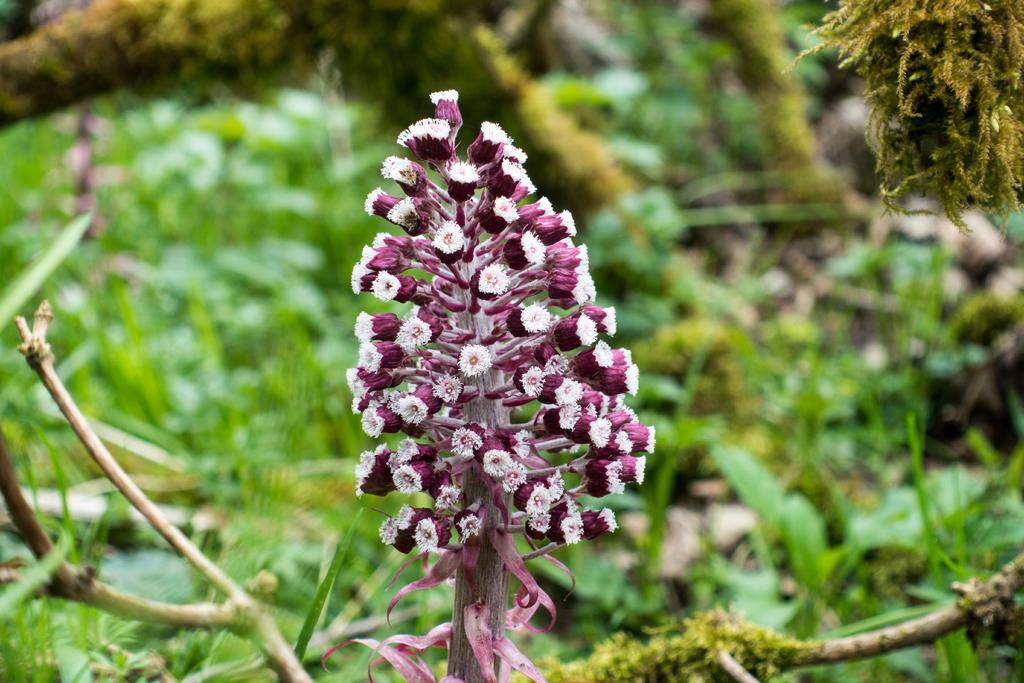What type of greenery is present in the image? The image contains greenery, but the specific type cannot be determined from the provided facts. What can be observed about the flowers in the image? There are flowers with stems in the image. What type of pancake is being served to the family in the image? There is no family or pancake present in the image; it only contains greenery and flowers with stems. How many beads are visible on the necklace in the image? There is no necklace or beads present in the image. 